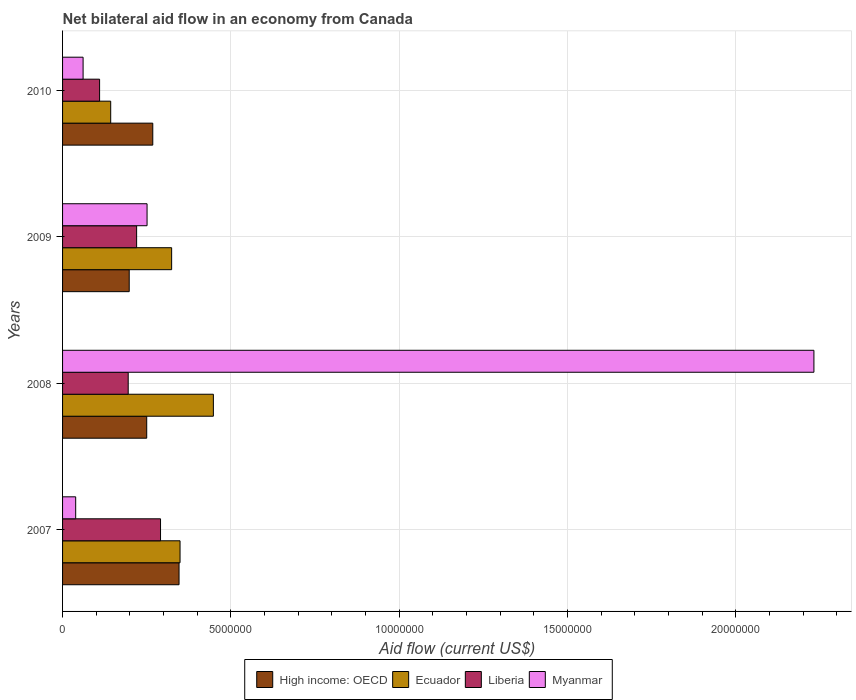How many different coloured bars are there?
Provide a short and direct response. 4. How many groups of bars are there?
Your answer should be very brief. 4. Are the number of bars per tick equal to the number of legend labels?
Provide a succinct answer. Yes. How many bars are there on the 3rd tick from the bottom?
Your answer should be very brief. 4. What is the net bilateral aid flow in Ecuador in 2010?
Your response must be concise. 1.43e+06. Across all years, what is the maximum net bilateral aid flow in Ecuador?
Ensure brevity in your answer.  4.48e+06. Across all years, what is the minimum net bilateral aid flow in Ecuador?
Provide a short and direct response. 1.43e+06. In which year was the net bilateral aid flow in Myanmar minimum?
Make the answer very short. 2007. What is the total net bilateral aid flow in Myanmar in the graph?
Offer a very short reply. 2.58e+07. What is the difference between the net bilateral aid flow in Myanmar in 2008 and that in 2010?
Offer a very short reply. 2.17e+07. What is the difference between the net bilateral aid flow in High income: OECD in 2008 and the net bilateral aid flow in Ecuador in 2007?
Ensure brevity in your answer.  -9.90e+05. What is the average net bilateral aid flow in Ecuador per year?
Offer a terse response. 3.16e+06. In the year 2008, what is the difference between the net bilateral aid flow in Liberia and net bilateral aid flow in High income: OECD?
Your answer should be very brief. -5.50e+05. What is the ratio of the net bilateral aid flow in High income: OECD in 2007 to that in 2010?
Make the answer very short. 1.29. Is the net bilateral aid flow in Ecuador in 2007 less than that in 2008?
Offer a very short reply. Yes. What is the difference between the highest and the second highest net bilateral aid flow in Myanmar?
Make the answer very short. 1.98e+07. What is the difference between the highest and the lowest net bilateral aid flow in Ecuador?
Ensure brevity in your answer.  3.05e+06. Is the sum of the net bilateral aid flow in Ecuador in 2007 and 2010 greater than the maximum net bilateral aid flow in High income: OECD across all years?
Your response must be concise. Yes. Is it the case that in every year, the sum of the net bilateral aid flow in Ecuador and net bilateral aid flow in Liberia is greater than the sum of net bilateral aid flow in High income: OECD and net bilateral aid flow in Myanmar?
Make the answer very short. No. What does the 1st bar from the top in 2010 represents?
Keep it short and to the point. Myanmar. What does the 4th bar from the bottom in 2010 represents?
Offer a terse response. Myanmar. Are the values on the major ticks of X-axis written in scientific E-notation?
Provide a succinct answer. No. How many legend labels are there?
Your response must be concise. 4. How are the legend labels stacked?
Your answer should be very brief. Horizontal. What is the title of the graph?
Offer a terse response. Net bilateral aid flow in an economy from Canada. What is the label or title of the Y-axis?
Your response must be concise. Years. What is the Aid flow (current US$) in High income: OECD in 2007?
Ensure brevity in your answer.  3.46e+06. What is the Aid flow (current US$) of Ecuador in 2007?
Offer a very short reply. 3.49e+06. What is the Aid flow (current US$) in Liberia in 2007?
Provide a short and direct response. 2.91e+06. What is the Aid flow (current US$) of High income: OECD in 2008?
Your answer should be compact. 2.50e+06. What is the Aid flow (current US$) in Ecuador in 2008?
Offer a very short reply. 4.48e+06. What is the Aid flow (current US$) in Liberia in 2008?
Your answer should be compact. 1.95e+06. What is the Aid flow (current US$) in Myanmar in 2008?
Give a very brief answer. 2.23e+07. What is the Aid flow (current US$) in High income: OECD in 2009?
Offer a terse response. 1.98e+06. What is the Aid flow (current US$) in Ecuador in 2009?
Keep it short and to the point. 3.24e+06. What is the Aid flow (current US$) in Liberia in 2009?
Ensure brevity in your answer.  2.20e+06. What is the Aid flow (current US$) in Myanmar in 2009?
Give a very brief answer. 2.51e+06. What is the Aid flow (current US$) in High income: OECD in 2010?
Your response must be concise. 2.68e+06. What is the Aid flow (current US$) of Ecuador in 2010?
Your answer should be compact. 1.43e+06. What is the Aid flow (current US$) of Liberia in 2010?
Your response must be concise. 1.10e+06. What is the Aid flow (current US$) in Myanmar in 2010?
Provide a succinct answer. 6.10e+05. Across all years, what is the maximum Aid flow (current US$) in High income: OECD?
Give a very brief answer. 3.46e+06. Across all years, what is the maximum Aid flow (current US$) of Ecuador?
Ensure brevity in your answer.  4.48e+06. Across all years, what is the maximum Aid flow (current US$) in Liberia?
Your answer should be compact. 2.91e+06. Across all years, what is the maximum Aid flow (current US$) in Myanmar?
Offer a terse response. 2.23e+07. Across all years, what is the minimum Aid flow (current US$) in High income: OECD?
Provide a succinct answer. 1.98e+06. Across all years, what is the minimum Aid flow (current US$) in Ecuador?
Keep it short and to the point. 1.43e+06. Across all years, what is the minimum Aid flow (current US$) in Liberia?
Provide a succinct answer. 1.10e+06. Across all years, what is the minimum Aid flow (current US$) in Myanmar?
Your answer should be very brief. 3.90e+05. What is the total Aid flow (current US$) in High income: OECD in the graph?
Provide a short and direct response. 1.06e+07. What is the total Aid flow (current US$) in Ecuador in the graph?
Your answer should be very brief. 1.26e+07. What is the total Aid flow (current US$) of Liberia in the graph?
Provide a succinct answer. 8.16e+06. What is the total Aid flow (current US$) of Myanmar in the graph?
Make the answer very short. 2.58e+07. What is the difference between the Aid flow (current US$) of High income: OECD in 2007 and that in 2008?
Give a very brief answer. 9.60e+05. What is the difference between the Aid flow (current US$) of Ecuador in 2007 and that in 2008?
Your answer should be very brief. -9.90e+05. What is the difference between the Aid flow (current US$) in Liberia in 2007 and that in 2008?
Offer a very short reply. 9.60e+05. What is the difference between the Aid flow (current US$) of Myanmar in 2007 and that in 2008?
Ensure brevity in your answer.  -2.19e+07. What is the difference between the Aid flow (current US$) of High income: OECD in 2007 and that in 2009?
Offer a very short reply. 1.48e+06. What is the difference between the Aid flow (current US$) of Ecuador in 2007 and that in 2009?
Your response must be concise. 2.50e+05. What is the difference between the Aid flow (current US$) in Liberia in 2007 and that in 2009?
Provide a succinct answer. 7.10e+05. What is the difference between the Aid flow (current US$) in Myanmar in 2007 and that in 2009?
Keep it short and to the point. -2.12e+06. What is the difference between the Aid flow (current US$) in High income: OECD in 2007 and that in 2010?
Your response must be concise. 7.80e+05. What is the difference between the Aid flow (current US$) in Ecuador in 2007 and that in 2010?
Your answer should be very brief. 2.06e+06. What is the difference between the Aid flow (current US$) in Liberia in 2007 and that in 2010?
Your response must be concise. 1.81e+06. What is the difference between the Aid flow (current US$) of High income: OECD in 2008 and that in 2009?
Ensure brevity in your answer.  5.20e+05. What is the difference between the Aid flow (current US$) of Ecuador in 2008 and that in 2009?
Offer a very short reply. 1.24e+06. What is the difference between the Aid flow (current US$) of Liberia in 2008 and that in 2009?
Ensure brevity in your answer.  -2.50e+05. What is the difference between the Aid flow (current US$) in Myanmar in 2008 and that in 2009?
Provide a succinct answer. 1.98e+07. What is the difference between the Aid flow (current US$) in Ecuador in 2008 and that in 2010?
Make the answer very short. 3.05e+06. What is the difference between the Aid flow (current US$) of Liberia in 2008 and that in 2010?
Make the answer very short. 8.50e+05. What is the difference between the Aid flow (current US$) of Myanmar in 2008 and that in 2010?
Your response must be concise. 2.17e+07. What is the difference between the Aid flow (current US$) in High income: OECD in 2009 and that in 2010?
Give a very brief answer. -7.00e+05. What is the difference between the Aid flow (current US$) in Ecuador in 2009 and that in 2010?
Offer a very short reply. 1.81e+06. What is the difference between the Aid flow (current US$) in Liberia in 2009 and that in 2010?
Keep it short and to the point. 1.10e+06. What is the difference between the Aid flow (current US$) in Myanmar in 2009 and that in 2010?
Your response must be concise. 1.90e+06. What is the difference between the Aid flow (current US$) of High income: OECD in 2007 and the Aid flow (current US$) of Ecuador in 2008?
Your response must be concise. -1.02e+06. What is the difference between the Aid flow (current US$) of High income: OECD in 2007 and the Aid flow (current US$) of Liberia in 2008?
Give a very brief answer. 1.51e+06. What is the difference between the Aid flow (current US$) of High income: OECD in 2007 and the Aid flow (current US$) of Myanmar in 2008?
Provide a short and direct response. -1.89e+07. What is the difference between the Aid flow (current US$) of Ecuador in 2007 and the Aid flow (current US$) of Liberia in 2008?
Offer a very short reply. 1.54e+06. What is the difference between the Aid flow (current US$) in Ecuador in 2007 and the Aid flow (current US$) in Myanmar in 2008?
Your response must be concise. -1.88e+07. What is the difference between the Aid flow (current US$) of Liberia in 2007 and the Aid flow (current US$) of Myanmar in 2008?
Offer a terse response. -1.94e+07. What is the difference between the Aid flow (current US$) of High income: OECD in 2007 and the Aid flow (current US$) of Liberia in 2009?
Offer a terse response. 1.26e+06. What is the difference between the Aid flow (current US$) in High income: OECD in 2007 and the Aid flow (current US$) in Myanmar in 2009?
Your answer should be very brief. 9.50e+05. What is the difference between the Aid flow (current US$) in Ecuador in 2007 and the Aid flow (current US$) in Liberia in 2009?
Offer a very short reply. 1.29e+06. What is the difference between the Aid flow (current US$) in Ecuador in 2007 and the Aid flow (current US$) in Myanmar in 2009?
Offer a terse response. 9.80e+05. What is the difference between the Aid flow (current US$) in High income: OECD in 2007 and the Aid flow (current US$) in Ecuador in 2010?
Keep it short and to the point. 2.03e+06. What is the difference between the Aid flow (current US$) in High income: OECD in 2007 and the Aid flow (current US$) in Liberia in 2010?
Make the answer very short. 2.36e+06. What is the difference between the Aid flow (current US$) of High income: OECD in 2007 and the Aid flow (current US$) of Myanmar in 2010?
Your answer should be compact. 2.85e+06. What is the difference between the Aid flow (current US$) of Ecuador in 2007 and the Aid flow (current US$) of Liberia in 2010?
Your answer should be compact. 2.39e+06. What is the difference between the Aid flow (current US$) in Ecuador in 2007 and the Aid flow (current US$) in Myanmar in 2010?
Offer a terse response. 2.88e+06. What is the difference between the Aid flow (current US$) of Liberia in 2007 and the Aid flow (current US$) of Myanmar in 2010?
Your answer should be very brief. 2.30e+06. What is the difference between the Aid flow (current US$) in High income: OECD in 2008 and the Aid flow (current US$) in Ecuador in 2009?
Offer a very short reply. -7.40e+05. What is the difference between the Aid flow (current US$) in Ecuador in 2008 and the Aid flow (current US$) in Liberia in 2009?
Keep it short and to the point. 2.28e+06. What is the difference between the Aid flow (current US$) of Ecuador in 2008 and the Aid flow (current US$) of Myanmar in 2009?
Your response must be concise. 1.97e+06. What is the difference between the Aid flow (current US$) in Liberia in 2008 and the Aid flow (current US$) in Myanmar in 2009?
Your answer should be compact. -5.60e+05. What is the difference between the Aid flow (current US$) of High income: OECD in 2008 and the Aid flow (current US$) of Ecuador in 2010?
Make the answer very short. 1.07e+06. What is the difference between the Aid flow (current US$) in High income: OECD in 2008 and the Aid flow (current US$) in Liberia in 2010?
Offer a terse response. 1.40e+06. What is the difference between the Aid flow (current US$) of High income: OECD in 2008 and the Aid flow (current US$) of Myanmar in 2010?
Offer a terse response. 1.89e+06. What is the difference between the Aid flow (current US$) of Ecuador in 2008 and the Aid flow (current US$) of Liberia in 2010?
Make the answer very short. 3.38e+06. What is the difference between the Aid flow (current US$) in Ecuador in 2008 and the Aid flow (current US$) in Myanmar in 2010?
Provide a short and direct response. 3.87e+06. What is the difference between the Aid flow (current US$) of Liberia in 2008 and the Aid flow (current US$) of Myanmar in 2010?
Provide a succinct answer. 1.34e+06. What is the difference between the Aid flow (current US$) of High income: OECD in 2009 and the Aid flow (current US$) of Ecuador in 2010?
Your answer should be compact. 5.50e+05. What is the difference between the Aid flow (current US$) of High income: OECD in 2009 and the Aid flow (current US$) of Liberia in 2010?
Provide a short and direct response. 8.80e+05. What is the difference between the Aid flow (current US$) of High income: OECD in 2009 and the Aid flow (current US$) of Myanmar in 2010?
Your response must be concise. 1.37e+06. What is the difference between the Aid flow (current US$) in Ecuador in 2009 and the Aid flow (current US$) in Liberia in 2010?
Your answer should be very brief. 2.14e+06. What is the difference between the Aid flow (current US$) in Ecuador in 2009 and the Aid flow (current US$) in Myanmar in 2010?
Keep it short and to the point. 2.63e+06. What is the difference between the Aid flow (current US$) in Liberia in 2009 and the Aid flow (current US$) in Myanmar in 2010?
Offer a very short reply. 1.59e+06. What is the average Aid flow (current US$) in High income: OECD per year?
Your answer should be compact. 2.66e+06. What is the average Aid flow (current US$) of Ecuador per year?
Make the answer very short. 3.16e+06. What is the average Aid flow (current US$) in Liberia per year?
Ensure brevity in your answer.  2.04e+06. What is the average Aid flow (current US$) of Myanmar per year?
Your answer should be compact. 6.46e+06. In the year 2007, what is the difference between the Aid flow (current US$) of High income: OECD and Aid flow (current US$) of Myanmar?
Give a very brief answer. 3.07e+06. In the year 2007, what is the difference between the Aid flow (current US$) of Ecuador and Aid flow (current US$) of Liberia?
Your answer should be very brief. 5.80e+05. In the year 2007, what is the difference between the Aid flow (current US$) of Ecuador and Aid flow (current US$) of Myanmar?
Give a very brief answer. 3.10e+06. In the year 2007, what is the difference between the Aid flow (current US$) of Liberia and Aid flow (current US$) of Myanmar?
Make the answer very short. 2.52e+06. In the year 2008, what is the difference between the Aid flow (current US$) of High income: OECD and Aid flow (current US$) of Ecuador?
Provide a succinct answer. -1.98e+06. In the year 2008, what is the difference between the Aid flow (current US$) in High income: OECD and Aid flow (current US$) in Liberia?
Ensure brevity in your answer.  5.50e+05. In the year 2008, what is the difference between the Aid flow (current US$) of High income: OECD and Aid flow (current US$) of Myanmar?
Make the answer very short. -1.98e+07. In the year 2008, what is the difference between the Aid flow (current US$) in Ecuador and Aid flow (current US$) in Liberia?
Offer a very short reply. 2.53e+06. In the year 2008, what is the difference between the Aid flow (current US$) in Ecuador and Aid flow (current US$) in Myanmar?
Provide a succinct answer. -1.78e+07. In the year 2008, what is the difference between the Aid flow (current US$) in Liberia and Aid flow (current US$) in Myanmar?
Your answer should be compact. -2.04e+07. In the year 2009, what is the difference between the Aid flow (current US$) in High income: OECD and Aid flow (current US$) in Ecuador?
Give a very brief answer. -1.26e+06. In the year 2009, what is the difference between the Aid flow (current US$) in High income: OECD and Aid flow (current US$) in Liberia?
Give a very brief answer. -2.20e+05. In the year 2009, what is the difference between the Aid flow (current US$) in High income: OECD and Aid flow (current US$) in Myanmar?
Your answer should be compact. -5.30e+05. In the year 2009, what is the difference between the Aid flow (current US$) in Ecuador and Aid flow (current US$) in Liberia?
Offer a terse response. 1.04e+06. In the year 2009, what is the difference between the Aid flow (current US$) in Ecuador and Aid flow (current US$) in Myanmar?
Your answer should be compact. 7.30e+05. In the year 2009, what is the difference between the Aid flow (current US$) in Liberia and Aid flow (current US$) in Myanmar?
Your response must be concise. -3.10e+05. In the year 2010, what is the difference between the Aid flow (current US$) of High income: OECD and Aid flow (current US$) of Ecuador?
Provide a succinct answer. 1.25e+06. In the year 2010, what is the difference between the Aid flow (current US$) in High income: OECD and Aid flow (current US$) in Liberia?
Your answer should be very brief. 1.58e+06. In the year 2010, what is the difference between the Aid flow (current US$) of High income: OECD and Aid flow (current US$) of Myanmar?
Give a very brief answer. 2.07e+06. In the year 2010, what is the difference between the Aid flow (current US$) of Ecuador and Aid flow (current US$) of Liberia?
Your response must be concise. 3.30e+05. In the year 2010, what is the difference between the Aid flow (current US$) in Ecuador and Aid flow (current US$) in Myanmar?
Keep it short and to the point. 8.20e+05. What is the ratio of the Aid flow (current US$) of High income: OECD in 2007 to that in 2008?
Offer a terse response. 1.38. What is the ratio of the Aid flow (current US$) of Ecuador in 2007 to that in 2008?
Your response must be concise. 0.78. What is the ratio of the Aid flow (current US$) of Liberia in 2007 to that in 2008?
Offer a terse response. 1.49. What is the ratio of the Aid flow (current US$) of Myanmar in 2007 to that in 2008?
Offer a terse response. 0.02. What is the ratio of the Aid flow (current US$) in High income: OECD in 2007 to that in 2009?
Make the answer very short. 1.75. What is the ratio of the Aid flow (current US$) of Ecuador in 2007 to that in 2009?
Ensure brevity in your answer.  1.08. What is the ratio of the Aid flow (current US$) of Liberia in 2007 to that in 2009?
Provide a succinct answer. 1.32. What is the ratio of the Aid flow (current US$) of Myanmar in 2007 to that in 2009?
Make the answer very short. 0.16. What is the ratio of the Aid flow (current US$) of High income: OECD in 2007 to that in 2010?
Your answer should be very brief. 1.29. What is the ratio of the Aid flow (current US$) in Ecuador in 2007 to that in 2010?
Provide a succinct answer. 2.44. What is the ratio of the Aid flow (current US$) of Liberia in 2007 to that in 2010?
Your answer should be very brief. 2.65. What is the ratio of the Aid flow (current US$) in Myanmar in 2007 to that in 2010?
Offer a terse response. 0.64. What is the ratio of the Aid flow (current US$) in High income: OECD in 2008 to that in 2009?
Your answer should be compact. 1.26. What is the ratio of the Aid flow (current US$) of Ecuador in 2008 to that in 2009?
Your answer should be very brief. 1.38. What is the ratio of the Aid flow (current US$) in Liberia in 2008 to that in 2009?
Offer a very short reply. 0.89. What is the ratio of the Aid flow (current US$) in Myanmar in 2008 to that in 2009?
Provide a succinct answer. 8.89. What is the ratio of the Aid flow (current US$) of High income: OECD in 2008 to that in 2010?
Offer a terse response. 0.93. What is the ratio of the Aid flow (current US$) in Ecuador in 2008 to that in 2010?
Keep it short and to the point. 3.13. What is the ratio of the Aid flow (current US$) of Liberia in 2008 to that in 2010?
Make the answer very short. 1.77. What is the ratio of the Aid flow (current US$) of Myanmar in 2008 to that in 2010?
Keep it short and to the point. 36.59. What is the ratio of the Aid flow (current US$) of High income: OECD in 2009 to that in 2010?
Make the answer very short. 0.74. What is the ratio of the Aid flow (current US$) of Ecuador in 2009 to that in 2010?
Your response must be concise. 2.27. What is the ratio of the Aid flow (current US$) in Liberia in 2009 to that in 2010?
Keep it short and to the point. 2. What is the ratio of the Aid flow (current US$) in Myanmar in 2009 to that in 2010?
Make the answer very short. 4.11. What is the difference between the highest and the second highest Aid flow (current US$) of High income: OECD?
Your answer should be compact. 7.80e+05. What is the difference between the highest and the second highest Aid flow (current US$) of Ecuador?
Make the answer very short. 9.90e+05. What is the difference between the highest and the second highest Aid flow (current US$) of Liberia?
Offer a very short reply. 7.10e+05. What is the difference between the highest and the second highest Aid flow (current US$) of Myanmar?
Offer a terse response. 1.98e+07. What is the difference between the highest and the lowest Aid flow (current US$) in High income: OECD?
Offer a very short reply. 1.48e+06. What is the difference between the highest and the lowest Aid flow (current US$) in Ecuador?
Your answer should be very brief. 3.05e+06. What is the difference between the highest and the lowest Aid flow (current US$) of Liberia?
Provide a succinct answer. 1.81e+06. What is the difference between the highest and the lowest Aid flow (current US$) of Myanmar?
Provide a succinct answer. 2.19e+07. 